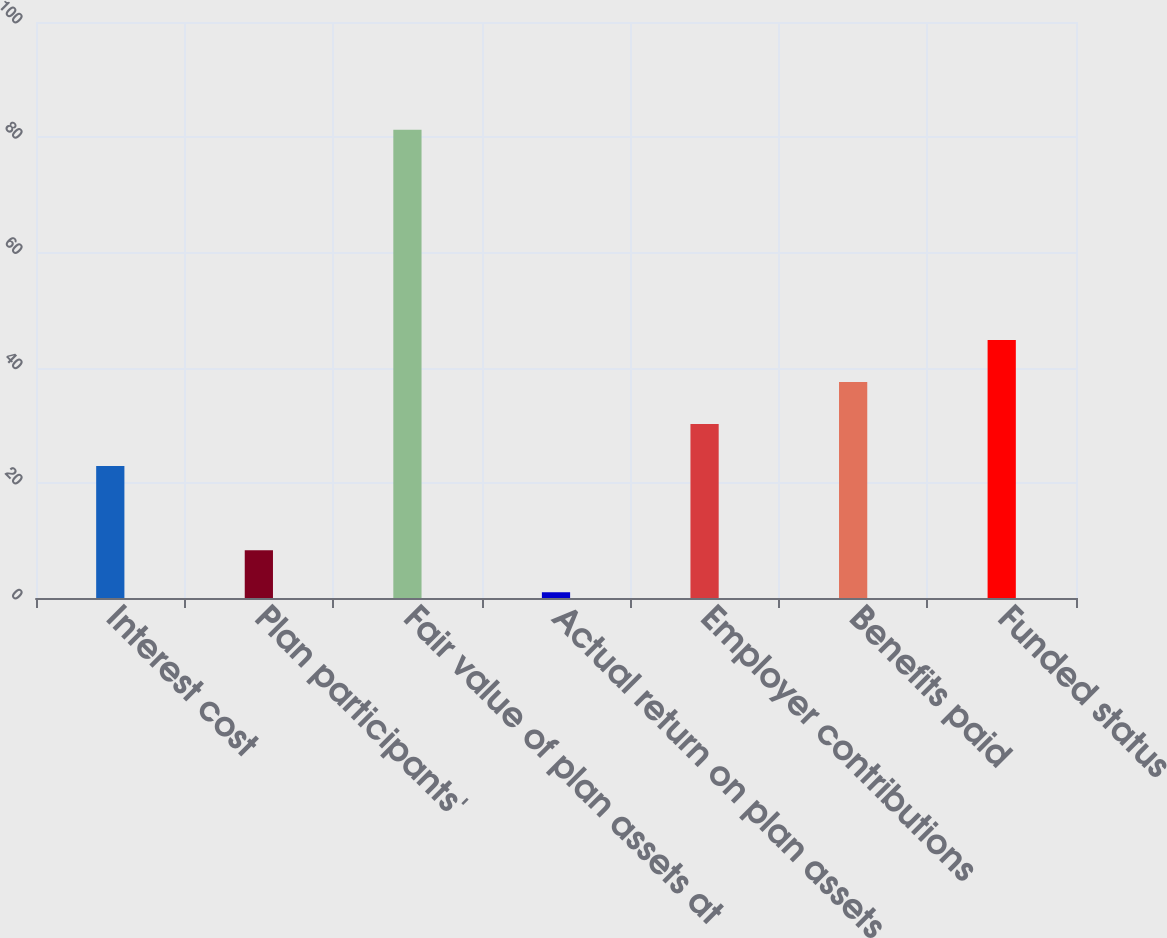Convert chart. <chart><loc_0><loc_0><loc_500><loc_500><bar_chart><fcel>Interest cost<fcel>Plan participants'<fcel>Fair value of plan assets at<fcel>Actual return on plan assets<fcel>Employer contributions<fcel>Benefits paid<fcel>Funded status<nl><fcel>22.9<fcel>8.3<fcel>81.3<fcel>1<fcel>30.2<fcel>37.5<fcel>44.8<nl></chart> 